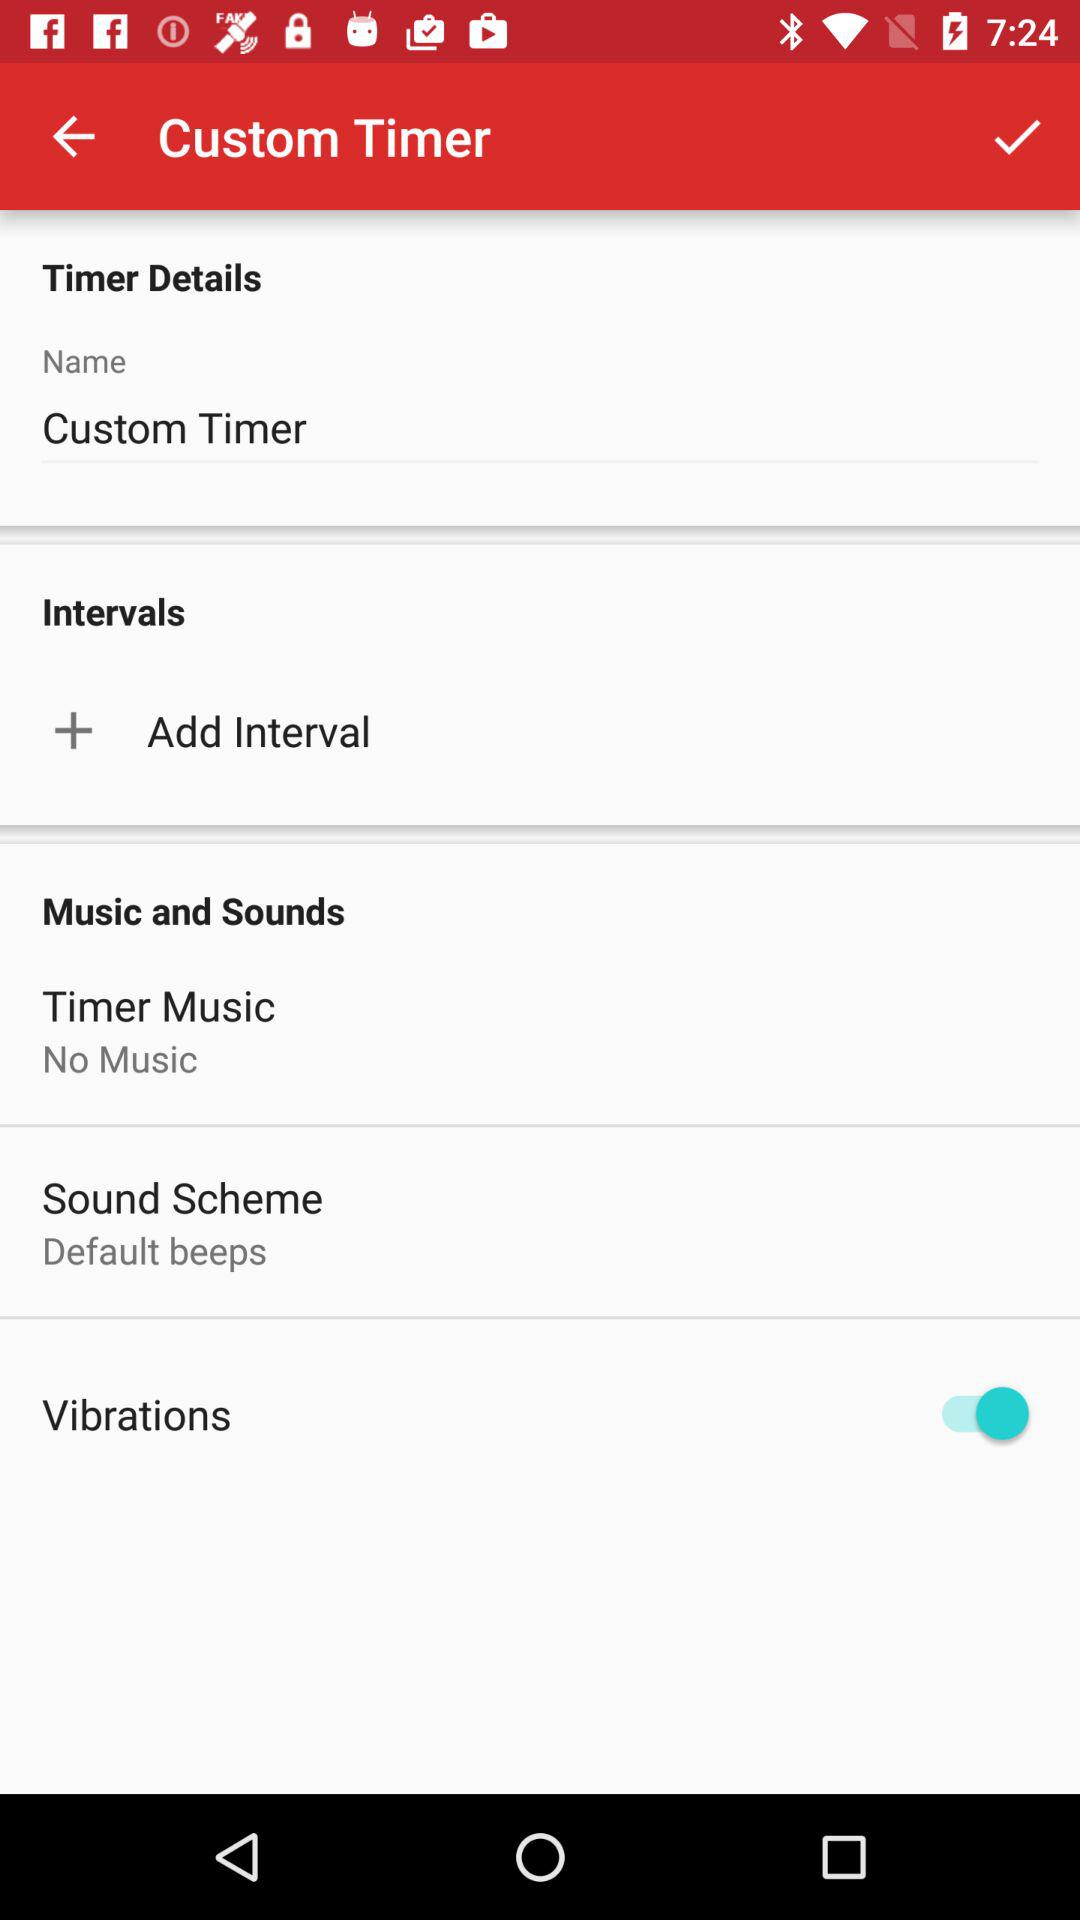How many music options are there?
Answer the question using a single word or phrase. 2 